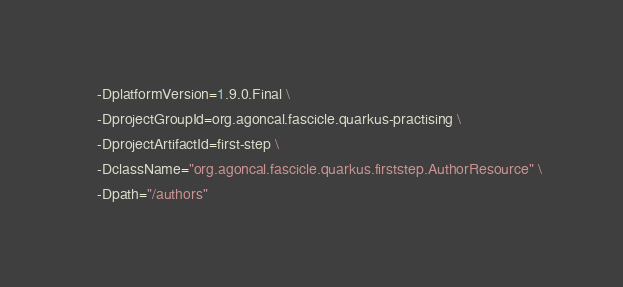Convert code to text. <code><loc_0><loc_0><loc_500><loc_500><_Bash_>    -DplatformVersion=1.9.0.Final \
    -DprojectGroupId=org.agoncal.fascicle.quarkus-practising \
    -DprojectArtifactId=first-step \
    -DclassName="org.agoncal.fascicle.quarkus.firststep.AuthorResource" \
    -Dpath="/authors"
</code> 